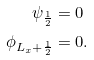<formula> <loc_0><loc_0><loc_500><loc_500>\psi _ { \frac { 1 } { 2 } } & = 0 \\ \phi _ { L _ { x } + \frac { 1 } { 2 } } & = 0 .</formula> 